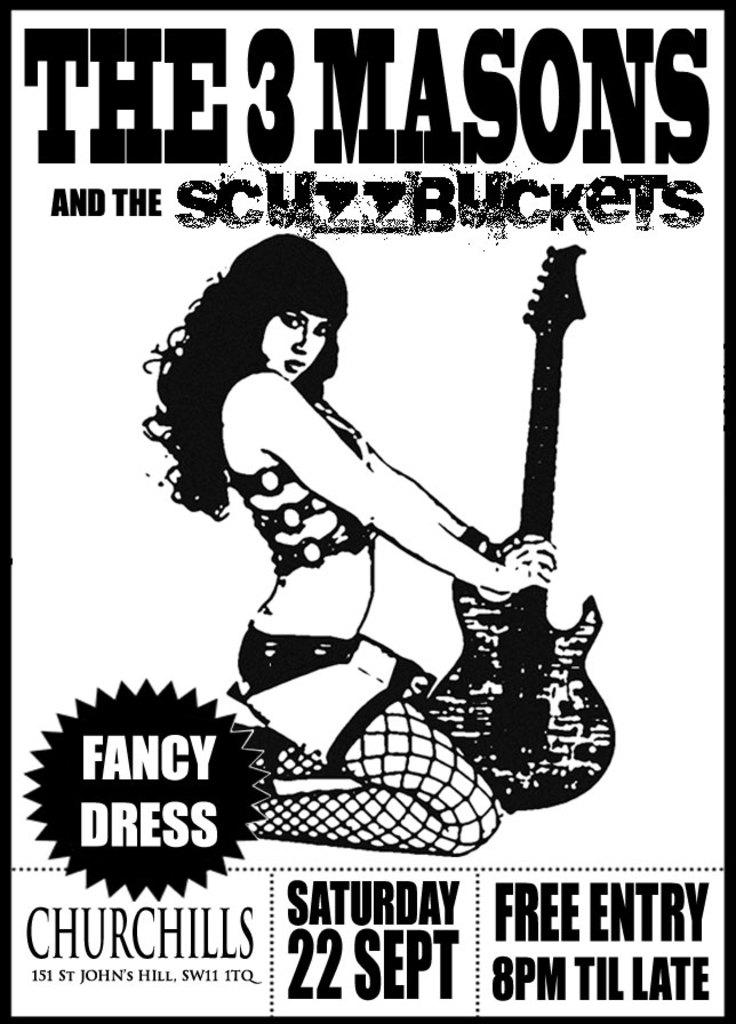<image>
Relay a brief, clear account of the picture shown. A poster for The 3 Masons and the Scuzzbuckets. 